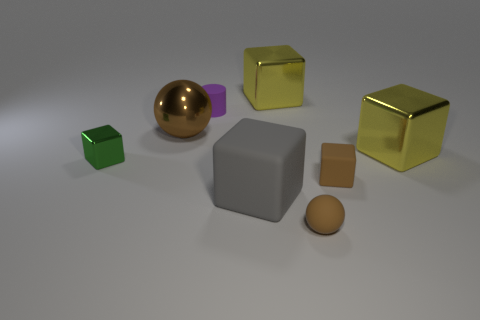There is a purple object; what shape is it? cylinder 